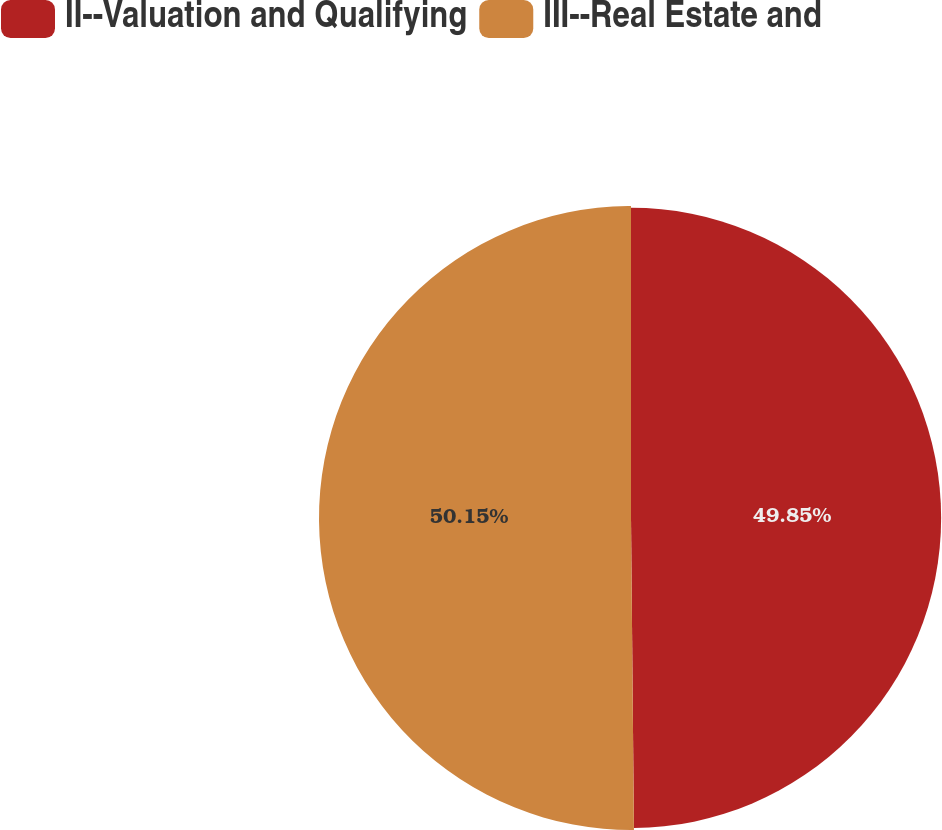Convert chart. <chart><loc_0><loc_0><loc_500><loc_500><pie_chart><fcel>II--Valuation and Qualifying<fcel>III--Real Estate and<nl><fcel>49.85%<fcel>50.15%<nl></chart> 